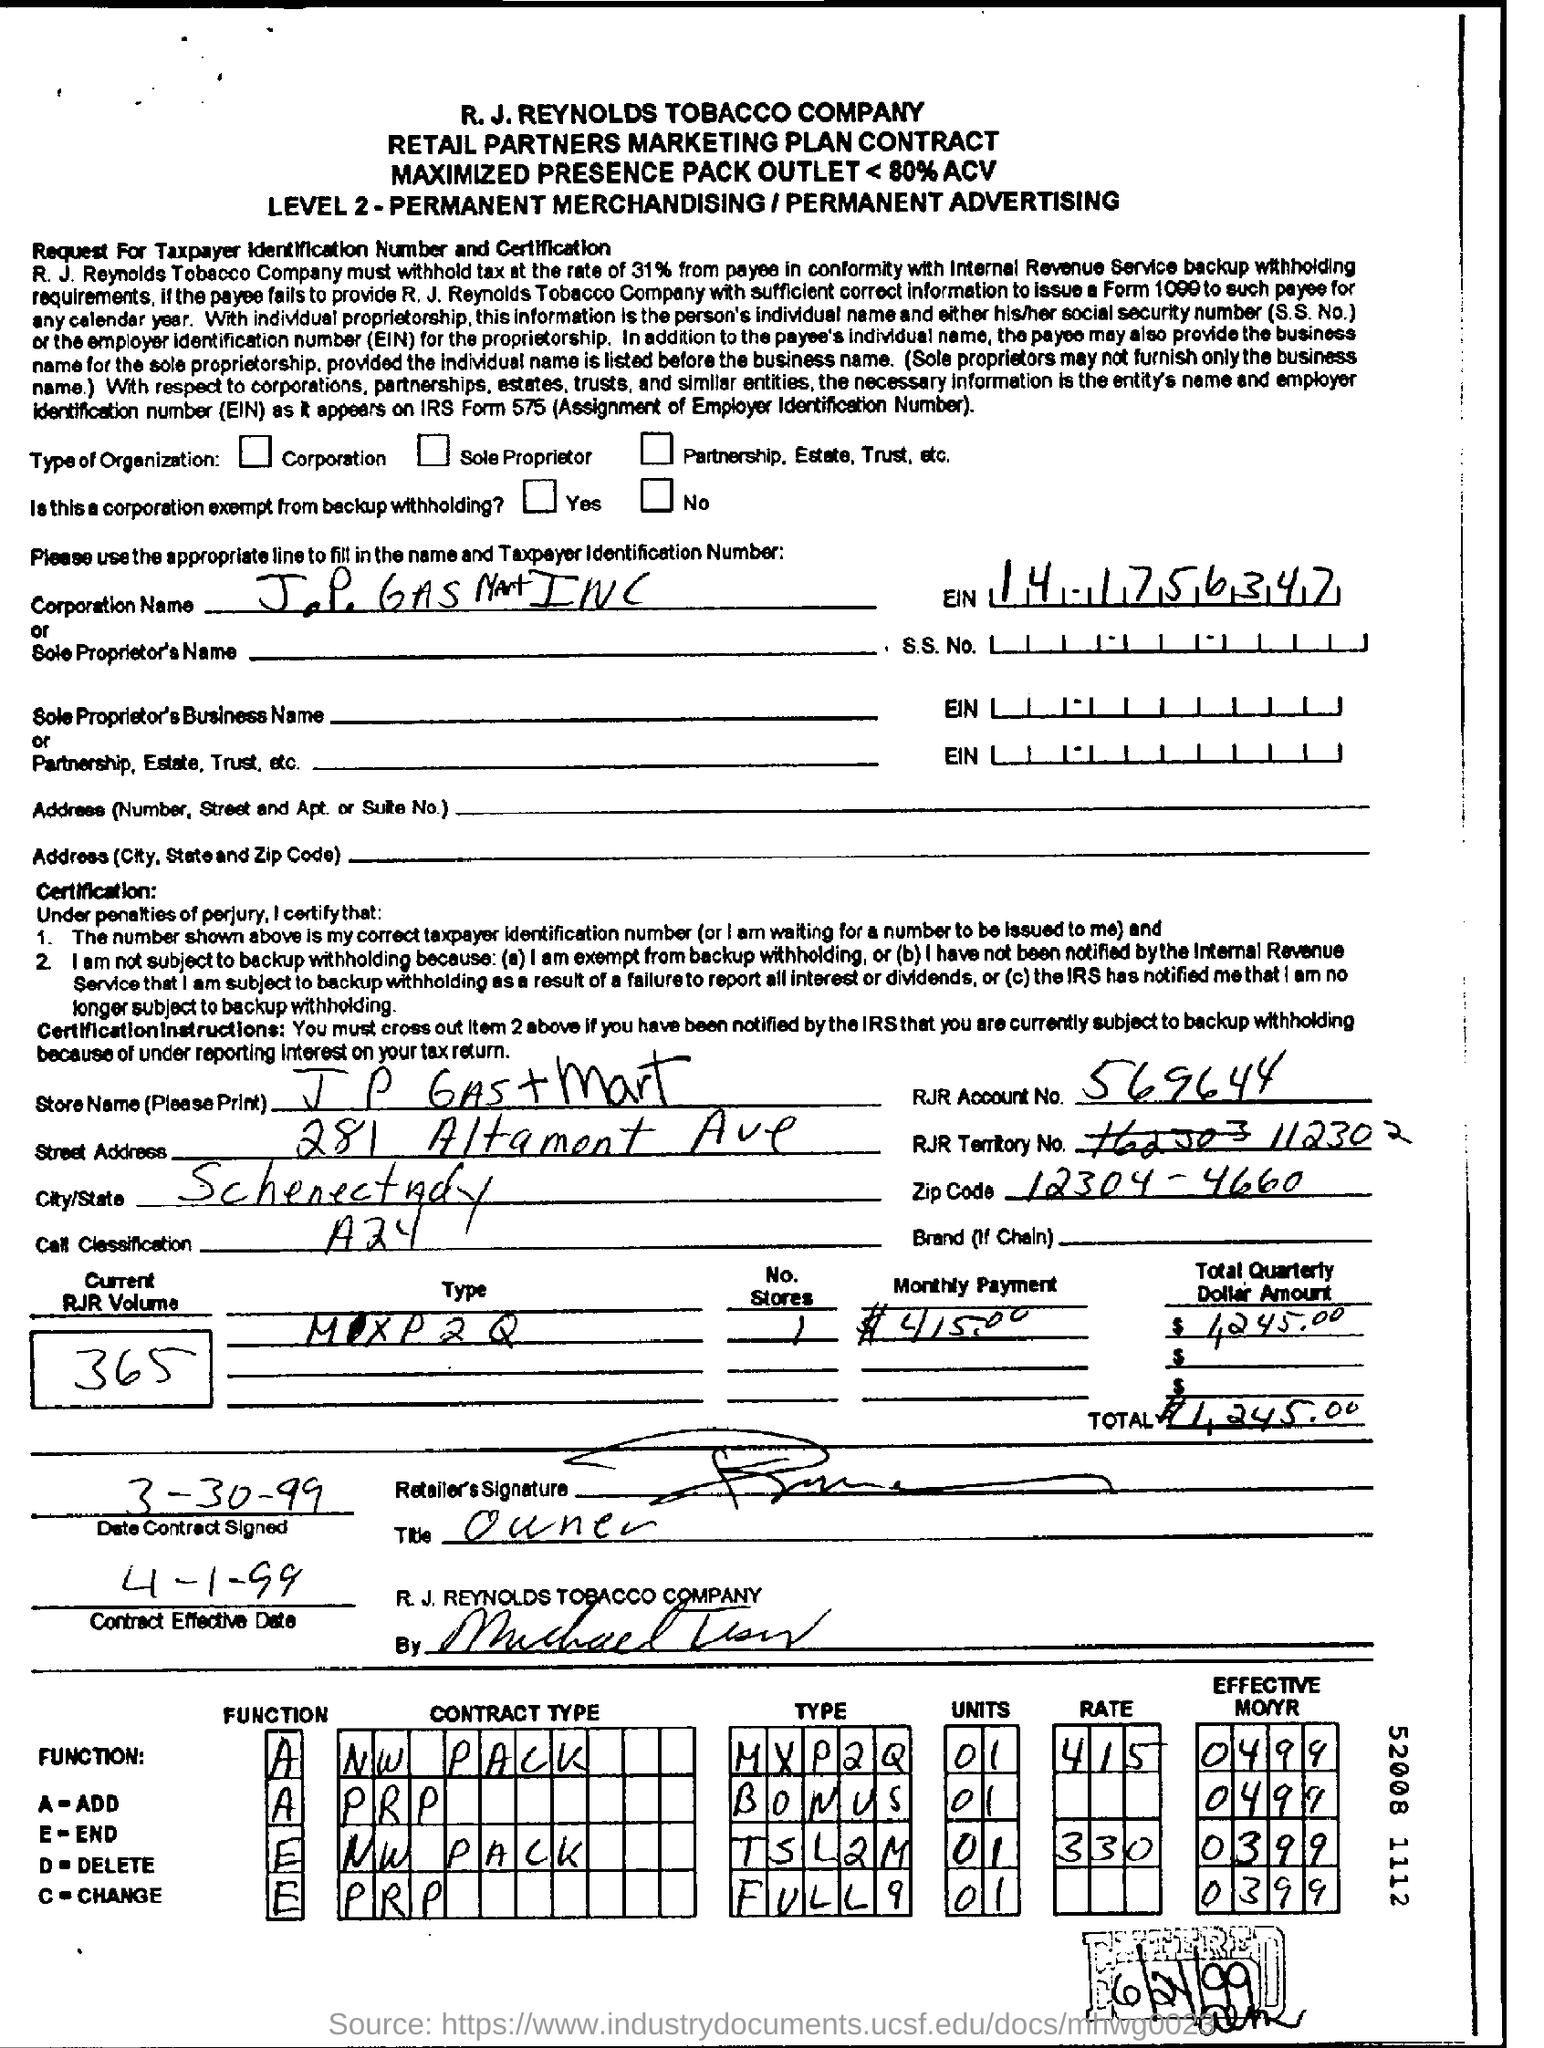What is the current RJR Volume no?
Your answer should be compact. 365. What is the EIN?
Give a very brief answer. 141756347. What is the current RJR Volume?
Provide a short and direct response. 365. What is the monthly payment mentioned?
Keep it short and to the point. $415,00. 